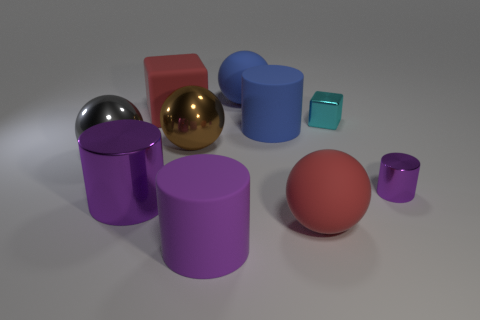What number of large purple cylinders are in front of the big red matte thing in front of the gray shiny ball?
Keep it short and to the point. 1. What number of tiny cyan blocks are the same material as the large red ball?
Keep it short and to the point. 0. What number of large things are either cyan cubes or metallic objects?
Ensure brevity in your answer.  3. What is the shape of the large thing that is behind the large brown shiny ball and to the left of the brown thing?
Provide a short and direct response. Cube. Do the small block and the blue cylinder have the same material?
Your response must be concise. No. What is the color of the cylinder that is the same size as the shiny block?
Provide a short and direct response. Purple. What is the color of the large thing that is on the left side of the large purple rubber thing and behind the large brown object?
Provide a succinct answer. Red. There is a rubber thing that is the same color as the big shiny cylinder; what size is it?
Your answer should be compact. Large. What shape is the large rubber thing that is the same color as the tiny cylinder?
Offer a terse response. Cylinder. How big is the cylinder behind the metal sphere that is to the left of the red matte object that is behind the brown metal ball?
Give a very brief answer. Large. 